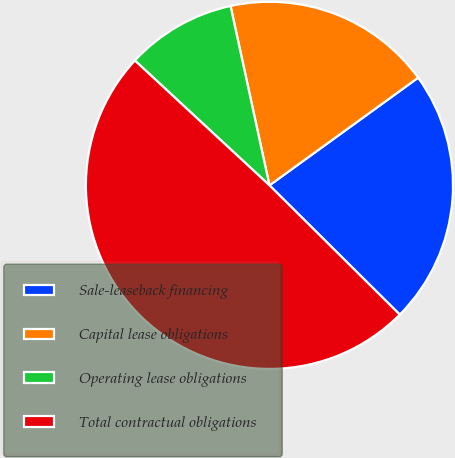Convert chart. <chart><loc_0><loc_0><loc_500><loc_500><pie_chart><fcel>Sale-leaseback financing<fcel>Capital lease obligations<fcel>Operating lease obligations<fcel>Total contractual obligations<nl><fcel>22.41%<fcel>18.43%<fcel>9.7%<fcel>49.47%<nl></chart> 